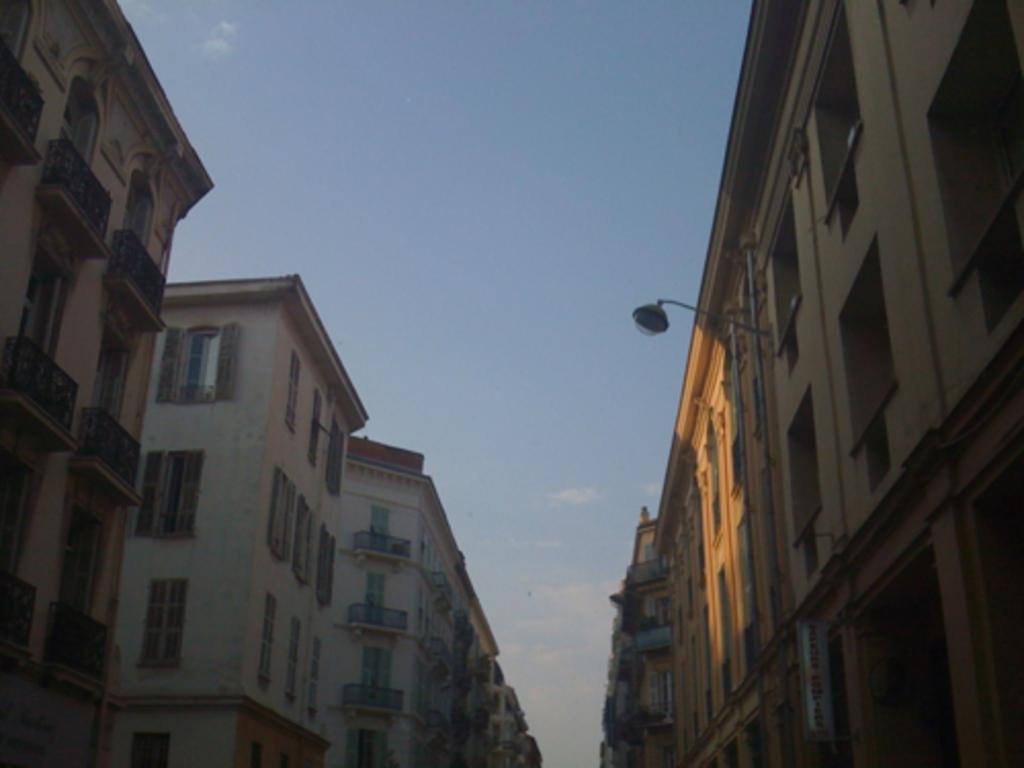What type of structures can be seen in the image? There are buildings in the image. Can you describe the lighting conditions in the image? There is light visible in the image. What can be seen in the sky in the image? There are clouds in the image. Where is the hoarding located in the image? The hoarding is in the bottom right-hand corner of the image. What rule is being discussed in the image? There is no discussion or rule present in the image; it features buildings, light, clouds, and a hoarding. 